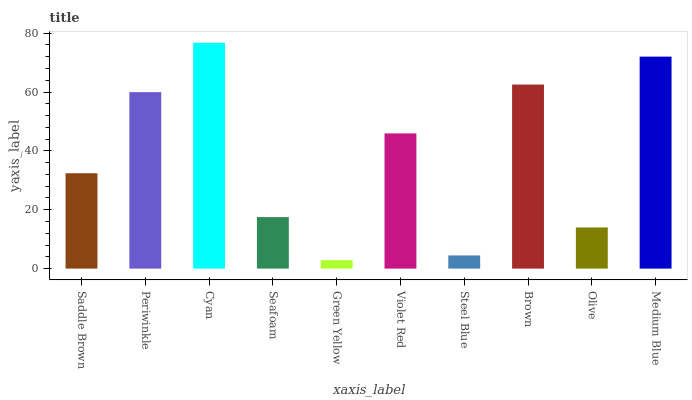Is Green Yellow the minimum?
Answer yes or no. Yes. Is Cyan the maximum?
Answer yes or no. Yes. Is Periwinkle the minimum?
Answer yes or no. No. Is Periwinkle the maximum?
Answer yes or no. No. Is Periwinkle greater than Saddle Brown?
Answer yes or no. Yes. Is Saddle Brown less than Periwinkle?
Answer yes or no. Yes. Is Saddle Brown greater than Periwinkle?
Answer yes or no. No. Is Periwinkle less than Saddle Brown?
Answer yes or no. No. Is Violet Red the high median?
Answer yes or no. Yes. Is Saddle Brown the low median?
Answer yes or no. Yes. Is Medium Blue the high median?
Answer yes or no. No. Is Green Yellow the low median?
Answer yes or no. No. 